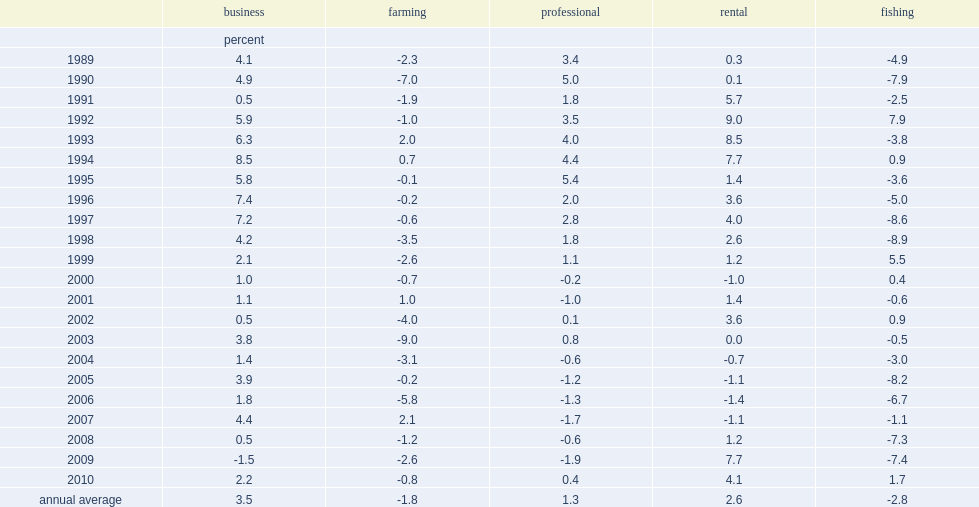What's the percent of the business category's annual growth rate from 1989 to 2010? 3.5. What's the percent of the rental category's annual growth rate from 1989 to 2010? 2.6. What's the percent of the professional sector's annual growth rate from 1989 to 2010? 1.3. What's the percent declined of the farming sector's annual growth rate from 1989 to 2010? 1.8. What's the percent that the fishing sector's annual growth rate declined from 1989 to 2010? 2.8. How did the number of self-employed people engaged in rental activities increased during 2008/2009 recessions? 7.7. 